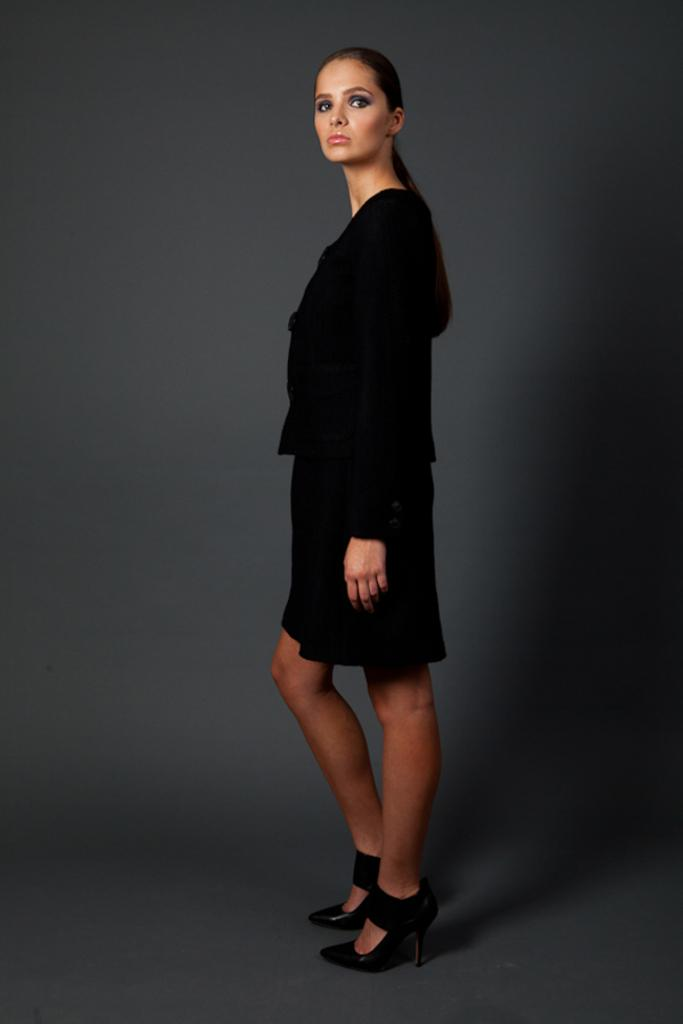Who is the main subject in the image? There is a lady in the center of the image. What is the lady wearing? The lady is wearing a black dress. What can be seen in the background of the image? There is a wall in the background of the image. What type of animal can be seen swimming in the ocean in the image? There is no animal or ocean present in the image; it features a lady in a black dress with a wall in the background. 